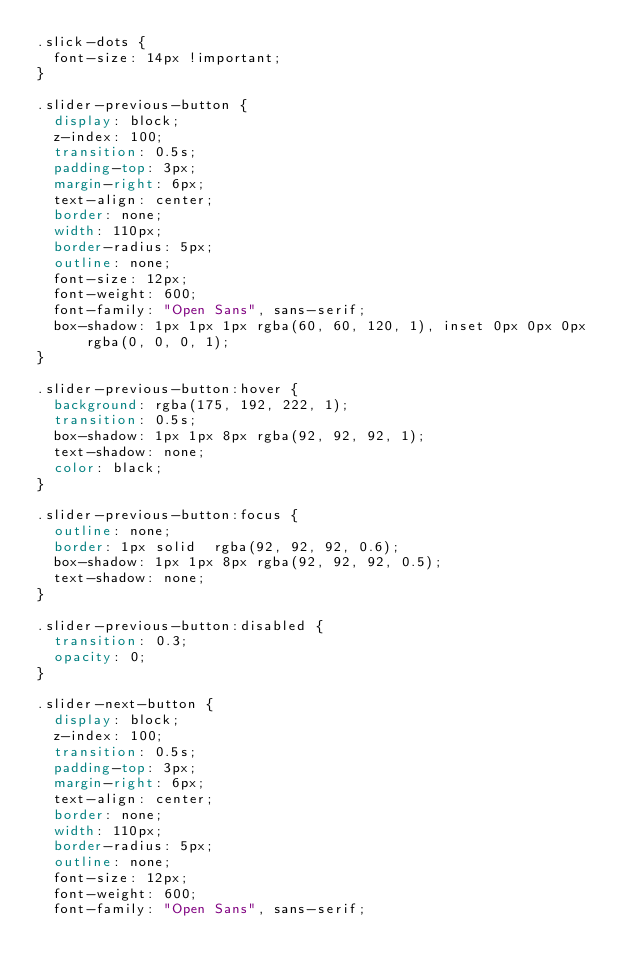Convert code to text. <code><loc_0><loc_0><loc_500><loc_500><_CSS_>.slick-dots {
	font-size: 14px !important;
}

.slider-previous-button {
	display: block;
	z-index: 100;
	transition: 0.5s;
	padding-top: 3px;
	margin-right: 6px;
	text-align: center;
	border: none;
	width: 110px;
	border-radius: 5px;
	outline: none;
	font-size: 12px;
	font-weight: 600;
	font-family: "Open Sans", sans-serif;
	box-shadow: 1px 1px 1px rgba(60, 60, 120, 1), inset 0px 0px 0px rgba(0, 0, 0, 1);
}

.slider-previous-button:hover {
	background: rgba(175, 192, 222, 1);
	transition: 0.5s;
	box-shadow: 1px 1px 8px rgba(92, 92, 92, 1);
	text-shadow: none;
	color: black;
}

.slider-previous-button:focus {
	outline: none;
	border: 1px solid  rgba(92, 92, 92, 0.6);
	box-shadow: 1px 1px 8px rgba(92, 92, 92, 0.5);
	text-shadow: none;
}

.slider-previous-button:disabled {
	transition: 0.3;
	opacity: 0;
}

.slider-next-button {
	display: block;
	z-index: 100;
	transition: 0.5s;
	padding-top: 3px;
	margin-right: 6px;
	text-align: center;
	border: none;
	width: 110px;
	border-radius: 5px;
	outline: none;
	font-size: 12px;
	font-weight: 600;
	font-family: "Open Sans", sans-serif;</code> 